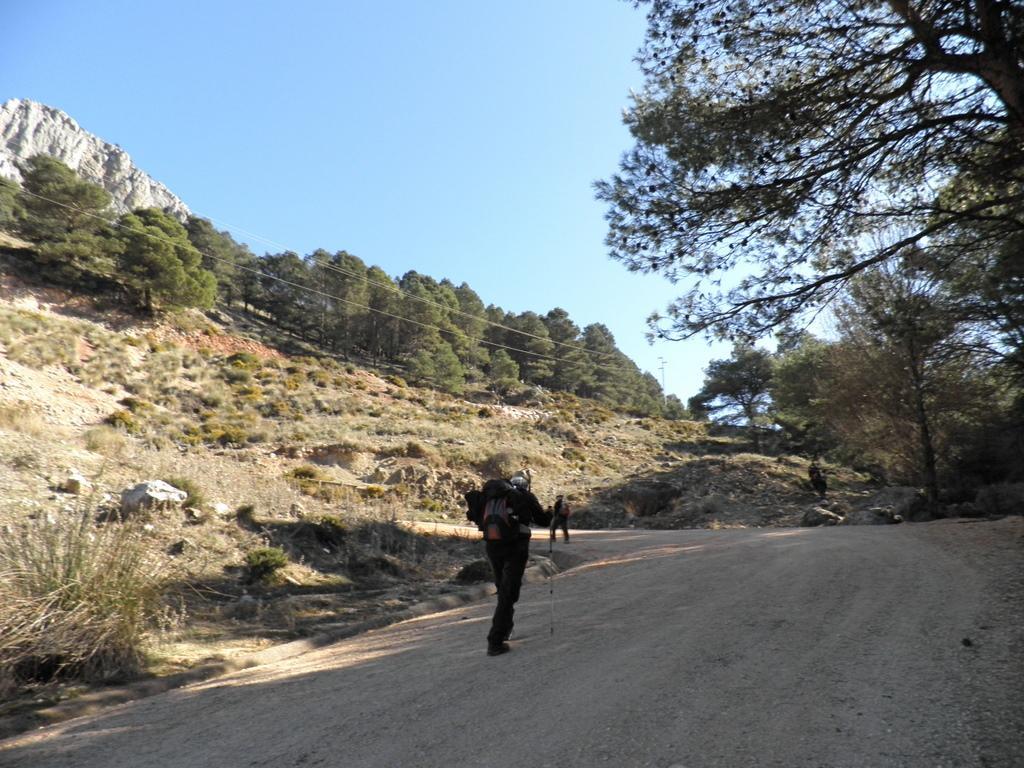How would you summarize this image in a sentence or two? In this image there is a road at the bottom. There are trees on the right corner. There are rocks and trees on the left corner and in the background. There is a person standing in the foreground. And there is sky at the top. 